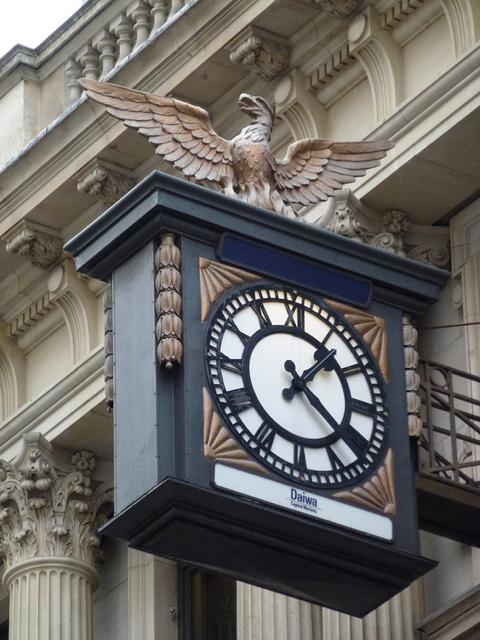What type of columns are on the building?
Give a very brief answer. Doric. Is there a real bird in this picture?
Keep it brief. No. What time is it?
Answer briefly. 1:20. 